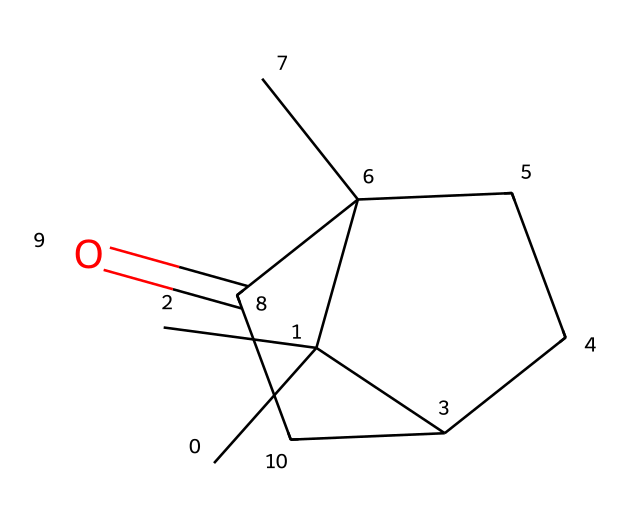What is the molecular formula of camphor? By examining the structure represented by the SMILES notation, we can count the individual carbon (C), hydrogen (H), and oxygen (O) atoms present. The structure reveals ten carbon atoms, sixteen hydrogen atoms, and one oxygen atom. Thus, the molecular formula is derived from these counts.
Answer: C10H16O How many rings are present in the camphor structure? The SMILES representation indicates the presence of two ring structures. The 'C2' notation in the SMILES shows that there are two interconnected cyclic components in the molecule. Hence, by looking for the 'C' labels and their structure, we can identify that there are two rings.
Answer: 2 What functional group is present in camphor? The SMILES indicates a carbonyl group (C=O) is present, specifically noted by the part 'C(=O)' within the structure. This particularly informs us that it is a ketone functional group, as it occurs between carbon atoms.
Answer: ketone What is the total number of hydrogen atoms in camphor? In the molecular structure derived from the SMILES, a detailed count shows there are 16 hydrogen atoms. Therefore, by analyzing the connections and saturation levels of the carbon atoms in the aliphatic compound, we can confirm this total.
Answer: 16 Is camphor symmetrical? Upon examining the structure's rings and branches, we can identify that the arrangement of carbon atoms is not symmetrical. The presence of asymmetric centers, specifically with respect to certain carbon atoms, contributes to this asymmetry, making it non-symmetrical.
Answer: No Which type of aliphatic compound does camphor belong to? As identified from the structure, camphor contains rings and a carbonyl group, classifying it as a bicyclic compound. By looking at the presence of rings and how the structure is organized, we can definitively determine the type it falls under.
Answer: bicyclic 